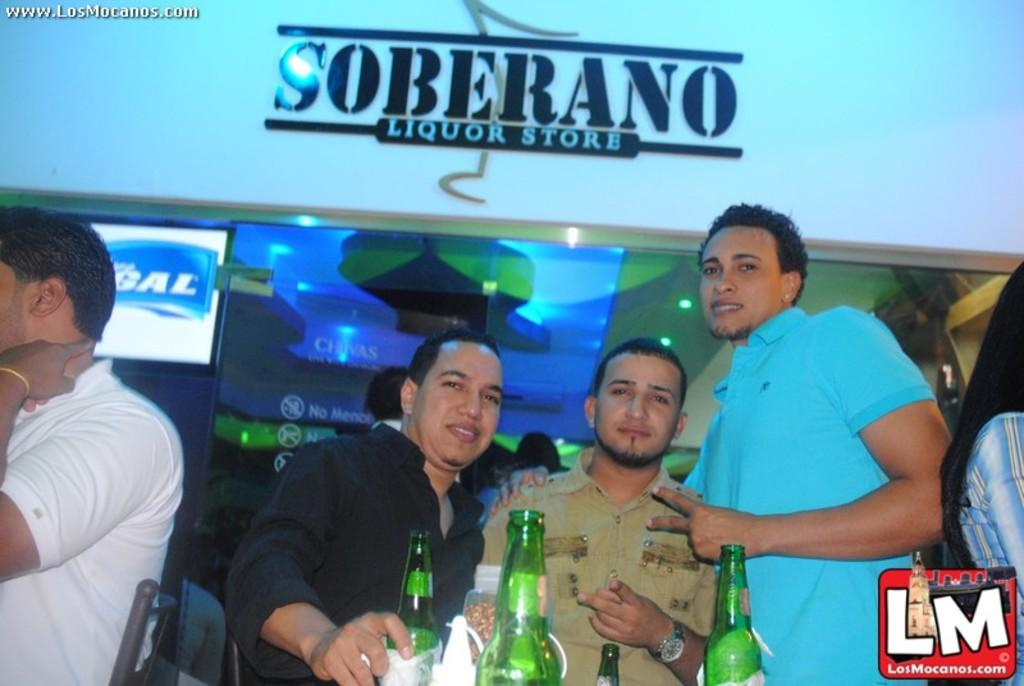<image>
Create a compact narrative representing the image presented. A group of men are partying under a sign that says Soberano Liquor Store. 